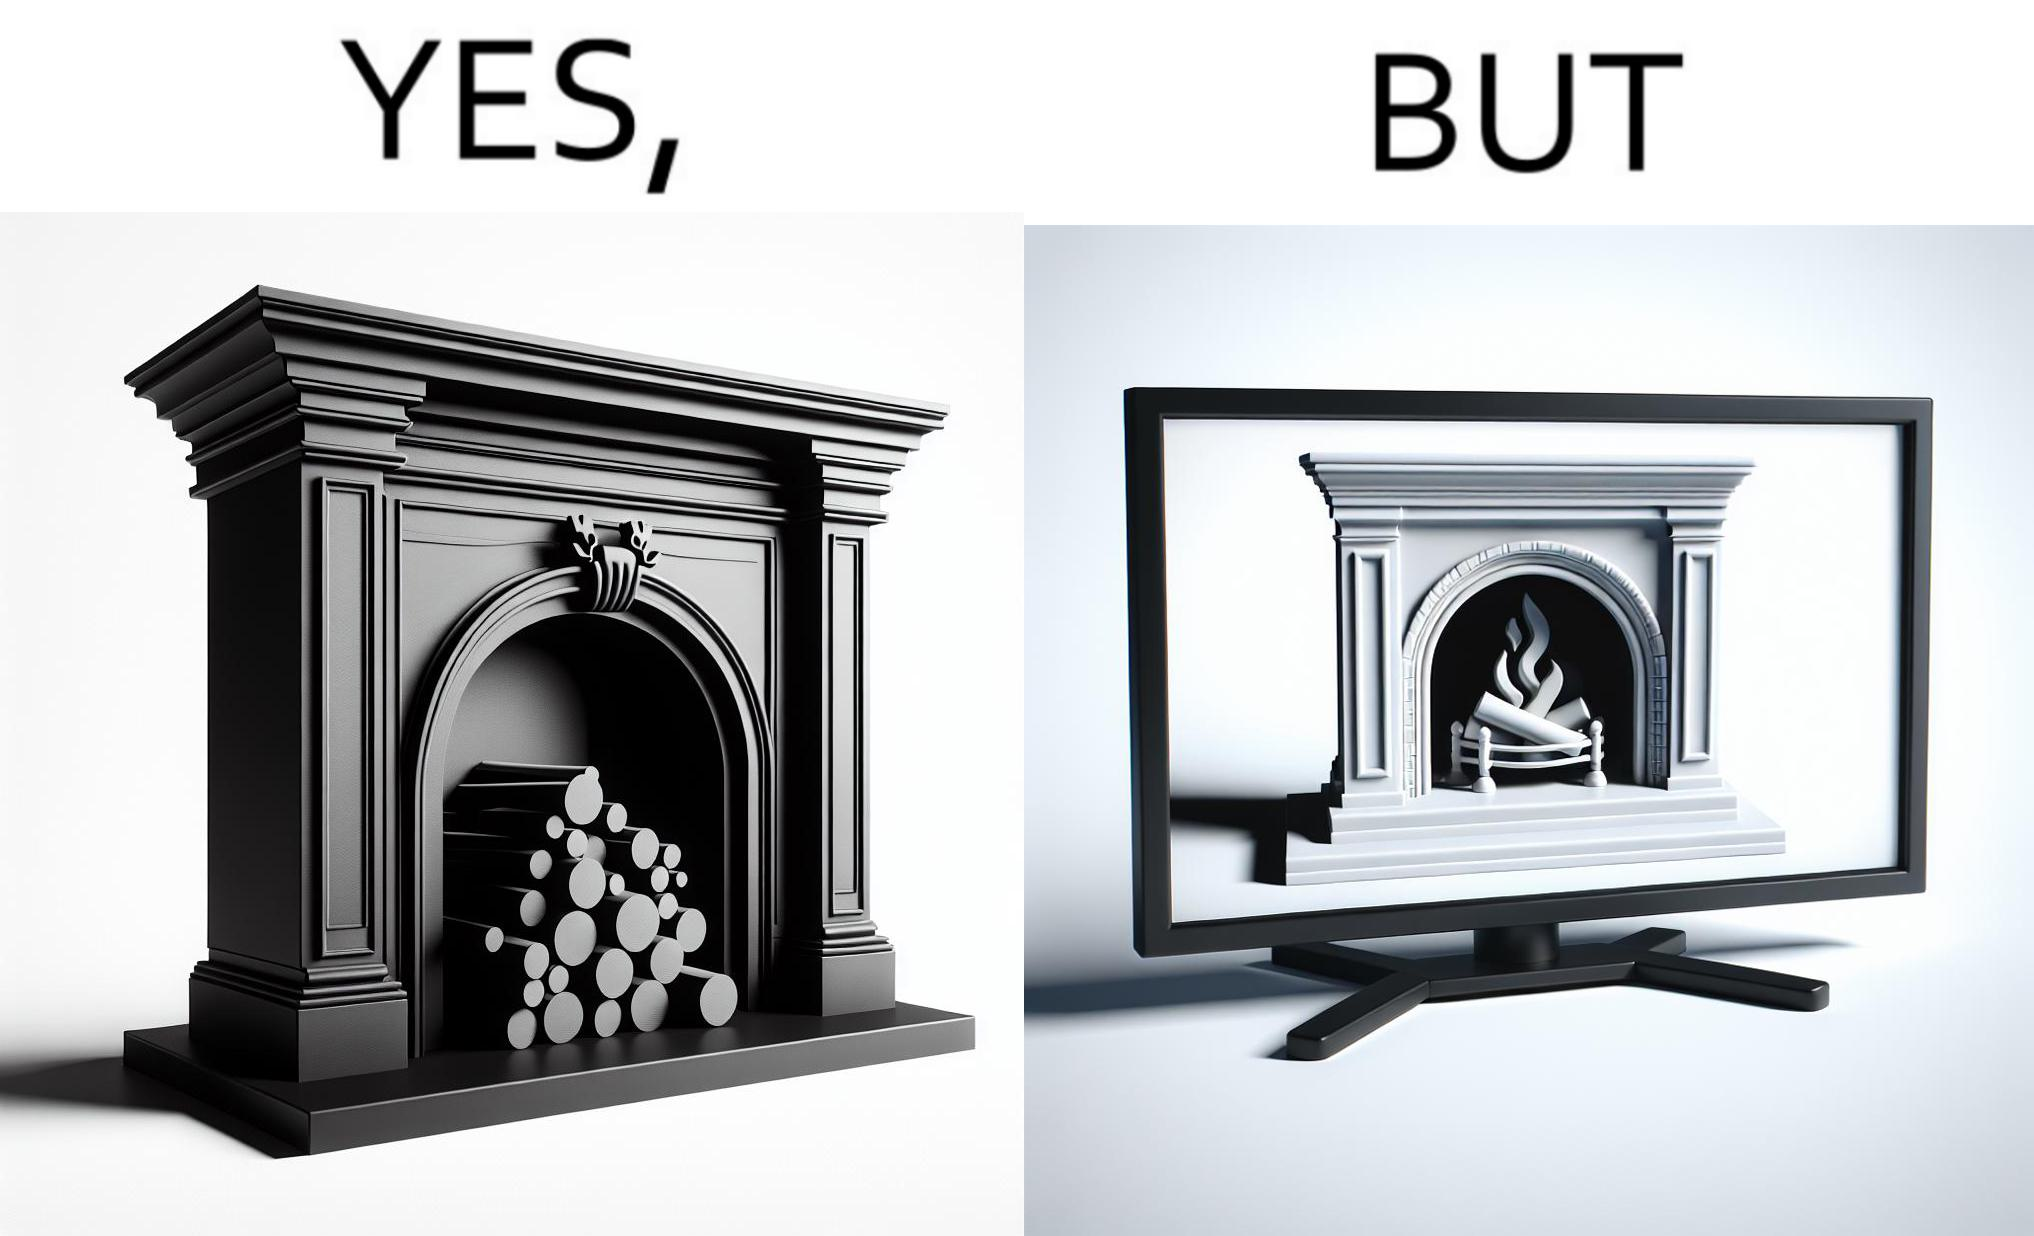What makes this image funny or satirical? The images are funny since they show how even though real fireplaces exist, people choose to be lazy and watch fireplaces on television because they dont want the inconveniences of cleaning up, etc. afterwards 